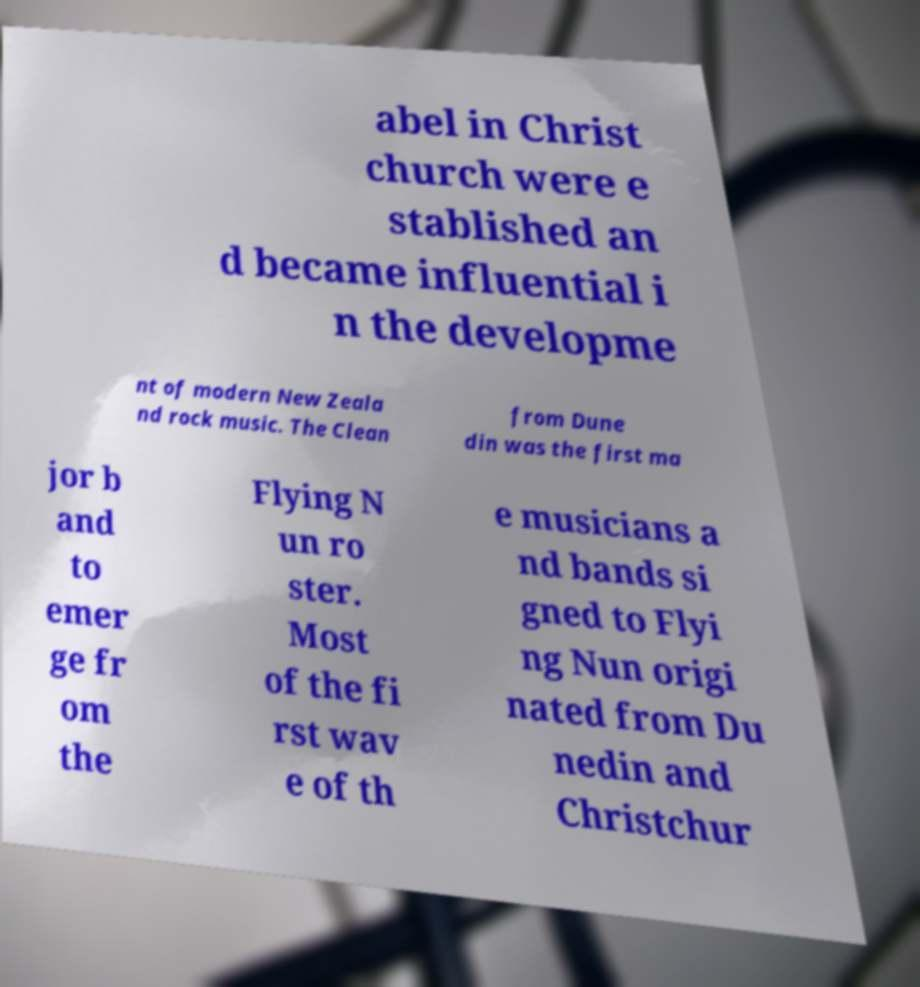For documentation purposes, I need the text within this image transcribed. Could you provide that? abel in Christ church were e stablished an d became influential i n the developme nt of modern New Zeala nd rock music. The Clean from Dune din was the first ma jor b and to emer ge fr om the Flying N un ro ster. Most of the fi rst wav e of th e musicians a nd bands si gned to Flyi ng Nun origi nated from Du nedin and Christchur 